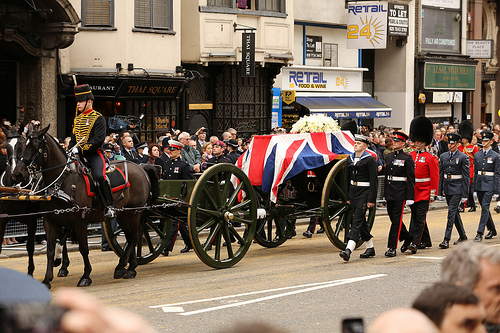Is the brown animal to the left of a man? Yes, the brown horse is to the left of the man. 